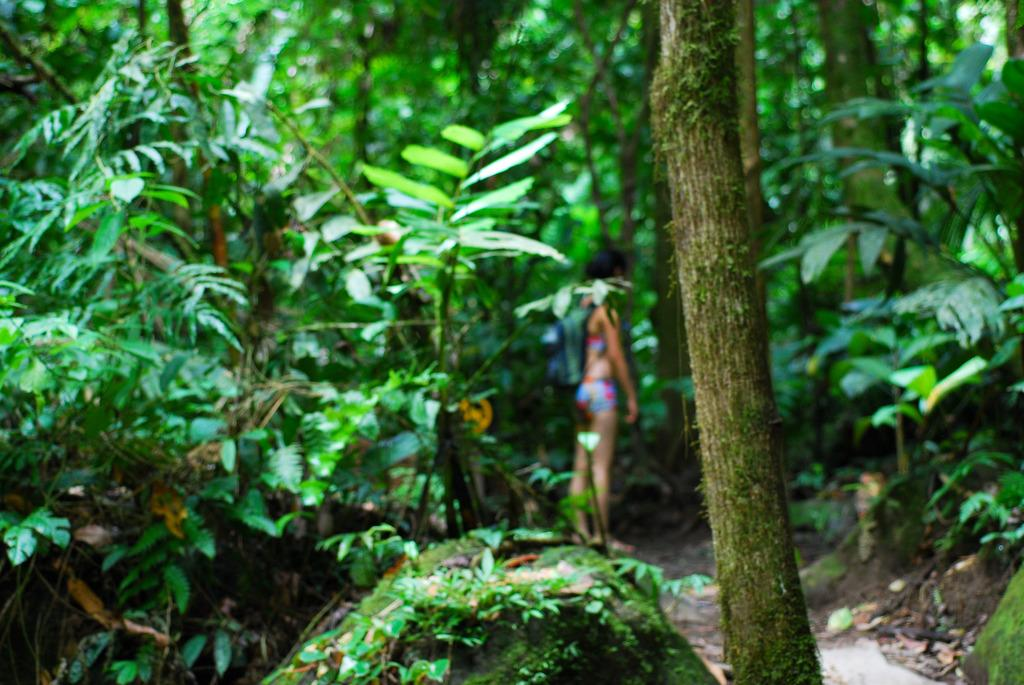Who is the main subject in the image? There is a girl in the center of the image. What is the girl wearing? The girl is wearing a bag. What can be seen in the background or surrounding the girl? There is greenery around the area of the image. What type of nerve is visible in the girl's ear in the image? There is no nerve visible in the girl's ear in the image, as the image does not show any close-up details of the girl's ear. 